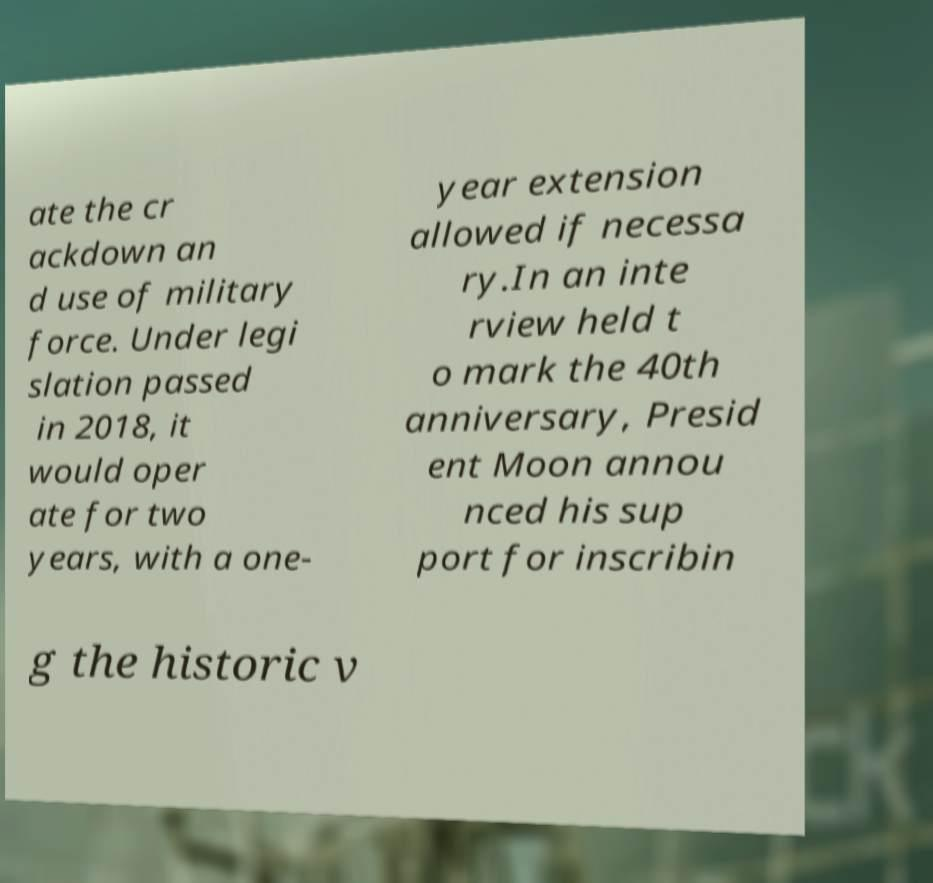For documentation purposes, I need the text within this image transcribed. Could you provide that? ate the cr ackdown an d use of military force. Under legi slation passed in 2018, it would oper ate for two years, with a one- year extension allowed if necessa ry.In an inte rview held t o mark the 40th anniversary, Presid ent Moon annou nced his sup port for inscribin g the historic v 